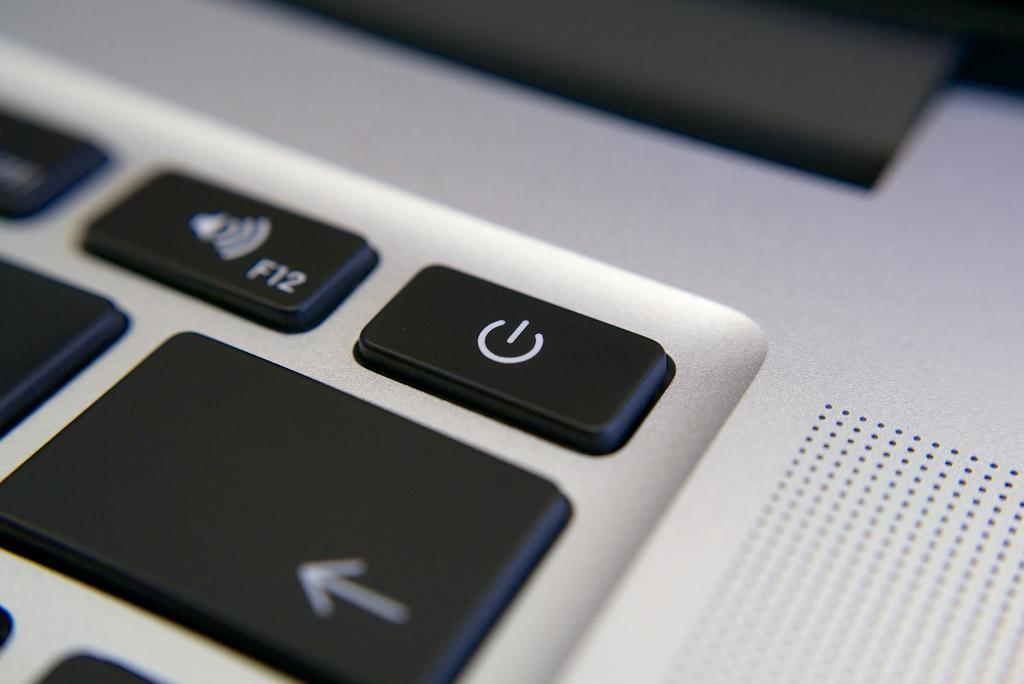<image>
Render a clear and concise summary of the photo. Laptop keyboard that shows the F12 key next to the power button. 